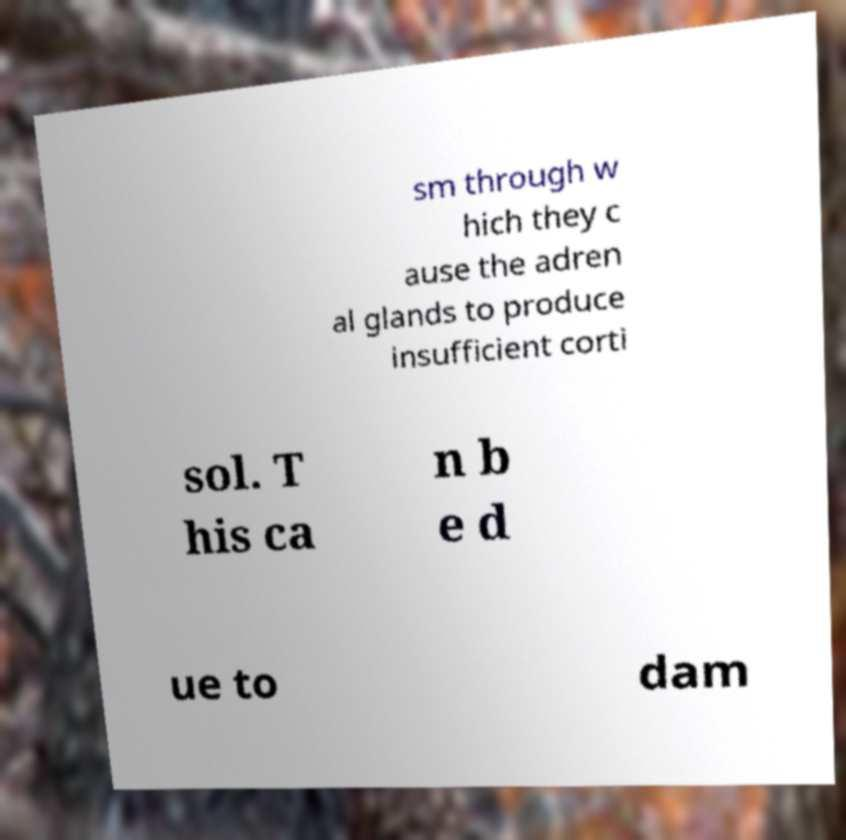Could you assist in decoding the text presented in this image and type it out clearly? sm through w hich they c ause the adren al glands to produce insufficient corti sol. T his ca n b e d ue to dam 